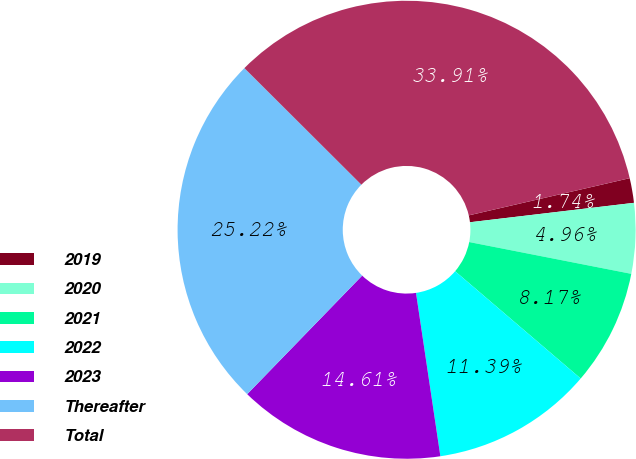<chart> <loc_0><loc_0><loc_500><loc_500><pie_chart><fcel>2019<fcel>2020<fcel>2021<fcel>2022<fcel>2023<fcel>Thereafter<fcel>Total<nl><fcel>1.74%<fcel>4.96%<fcel>8.17%<fcel>11.39%<fcel>14.61%<fcel>25.22%<fcel>33.91%<nl></chart> 